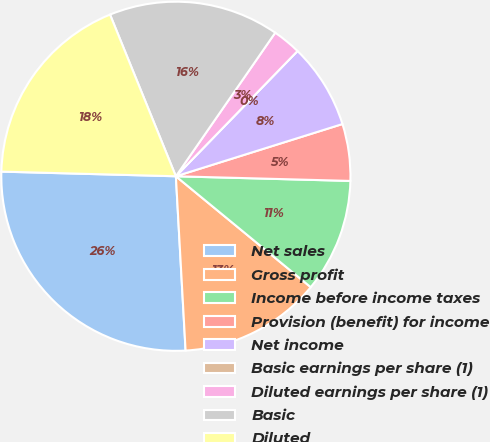<chart> <loc_0><loc_0><loc_500><loc_500><pie_chart><fcel>Net sales<fcel>Gross profit<fcel>Income before income taxes<fcel>Provision (benefit) for income<fcel>Net income<fcel>Basic earnings per share (1)<fcel>Diluted earnings per share (1)<fcel>Basic<fcel>Diluted<nl><fcel>26.31%<fcel>13.16%<fcel>10.53%<fcel>5.26%<fcel>7.9%<fcel>0.0%<fcel>2.63%<fcel>15.79%<fcel>18.42%<nl></chart> 